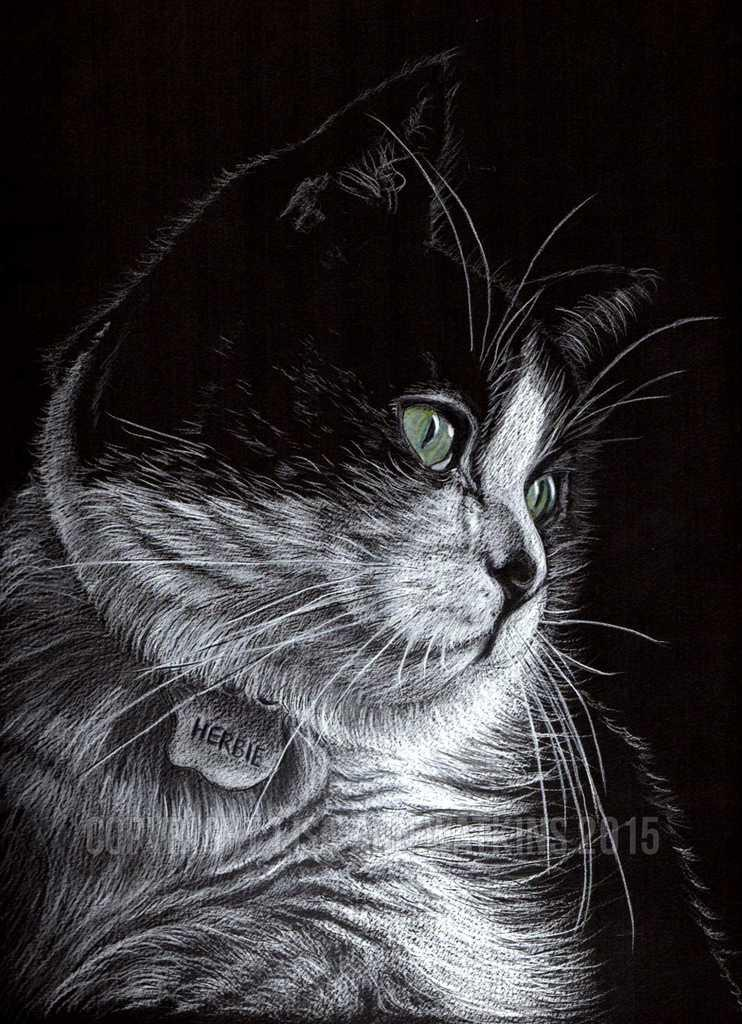What is the main subject of the image? There is a drawing of a cat in the center of the image. Can you see any rays of sunlight reflecting off the lake in the image? There is no lake or sunlight present in the image; it features a drawing of a cat. What type of cork is used to seal the cat's drawing in the image? There is no cork or any sealing method mentioned in the image, as it is a drawing of a cat. 